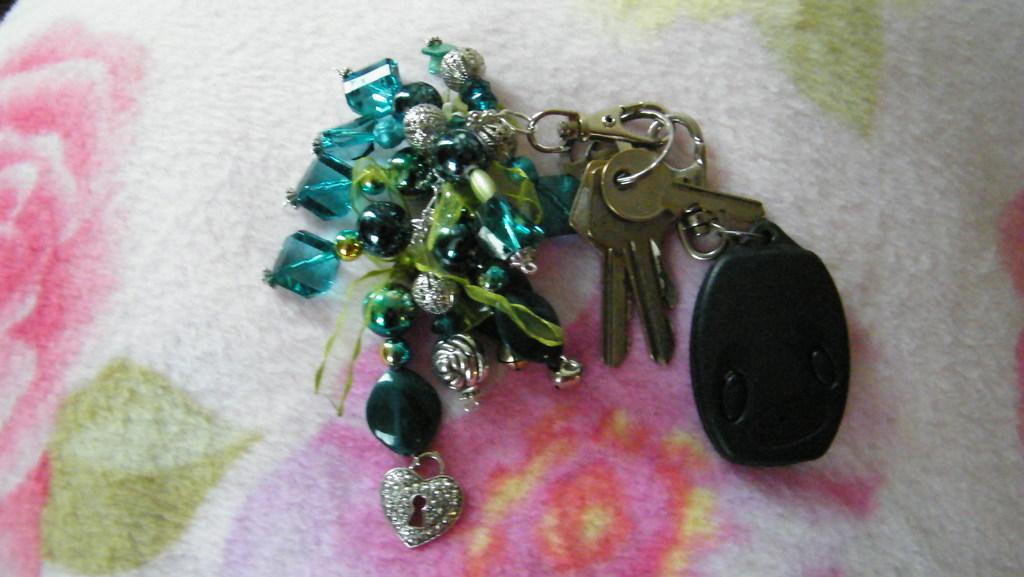What is attached to the keychain in the image? There are keys on a keychain in the image. What other object can be seen in the image? There is a remote in the image. What is the third item visible in the image? There is a blanket in the image. Can you see a river flowing in the image? No, there is no river present in the image. What type of brush is being used to clean the keys on the keychain? There is no brush visible in the image, as it only features keys on a keychain, a remote, and a blanket. 